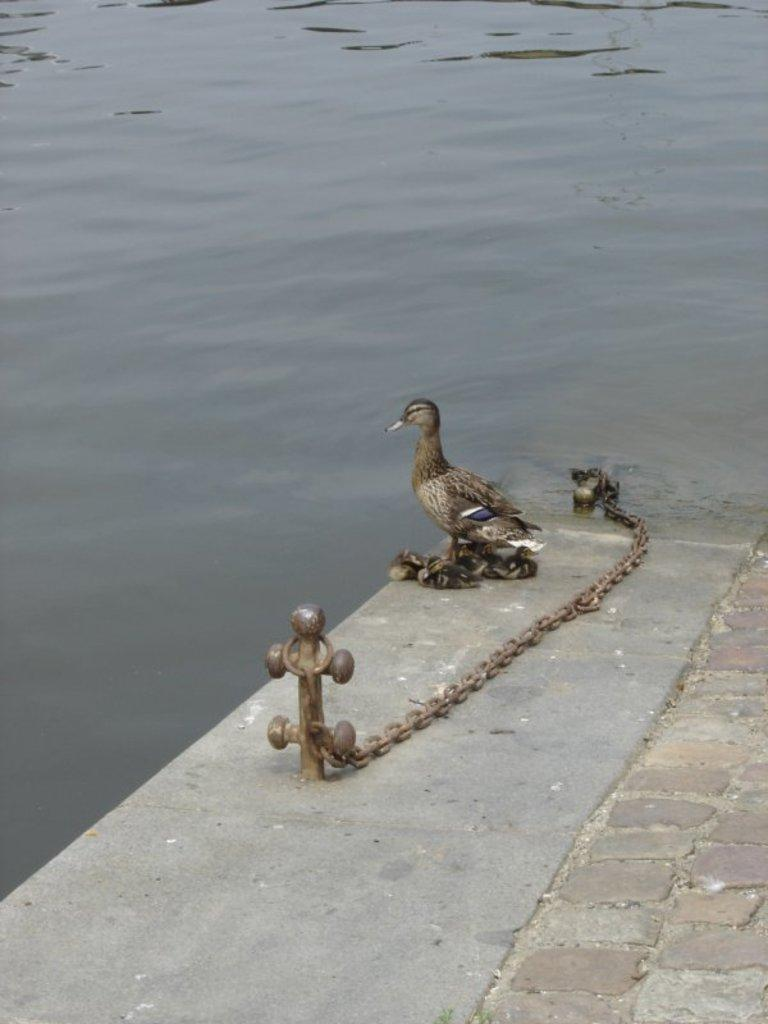What is present in the image that resembles a linking structure? There is a chain in the image. What type of animal can be seen in the image? There is a duck in the image. Are there any baby ducks in the image? Yes, there are ducklings in the image. Where are the duck and ducklings located? The duck and ducklings are on a surface in the image. What can be seen in the background of the image? There is water visible in the background of the image. What type of pot is being used to move the duck and ducklings in the image? There is no pot present in the image, and the duck and ducklings are not being moved by any object. 